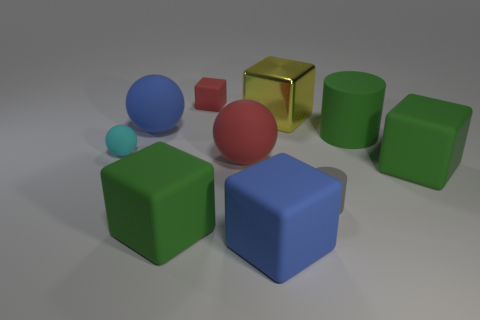What number of green matte things are behind the large green matte thing on the left side of the tiny gray rubber thing?
Your answer should be compact. 2. There is a yellow shiny thing; is its size the same as the blue matte object that is left of the blue matte cube?
Your answer should be very brief. Yes. Do the blue matte sphere and the yellow thing have the same size?
Offer a very short reply. Yes. Is there a cyan rubber ball of the same size as the gray matte cylinder?
Ensure brevity in your answer.  Yes. There is a cylinder that is to the right of the gray cylinder; what is it made of?
Keep it short and to the point. Rubber. The small cylinder that is the same material as the tiny red object is what color?
Provide a short and direct response. Gray. What number of matte objects are big red things or gray objects?
Your answer should be very brief. 2. There is a gray object that is the same size as the cyan matte sphere; what is its shape?
Your answer should be compact. Cylinder. What number of objects are big spheres left of the metallic object or cylinders in front of the cyan matte thing?
Offer a terse response. 3. There is a cylinder that is the same size as the shiny cube; what is its material?
Your response must be concise. Rubber. 